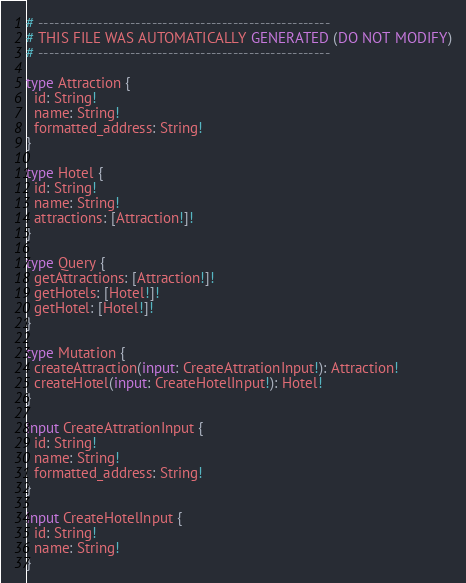Convert code to text. <code><loc_0><loc_0><loc_500><loc_500><_SQL_># ------------------------------------------------------
# THIS FILE WAS AUTOMATICALLY GENERATED (DO NOT MODIFY)
# ------------------------------------------------------

type Attraction {
  id: String!
  name: String!
  formatted_address: String!
}

type Hotel {
  id: String!
  name: String!
  attractions: [Attraction!]!
}

type Query {
  getAttractions: [Attraction!]!
  getHotels: [Hotel!]!
  getHotel: [Hotel!]!
}

type Mutation {
  createAttraction(input: CreateAttrationInput!): Attraction!
  createHotel(input: CreateHotelInput!): Hotel!
}

input CreateAttrationInput {
  id: String!
  name: String!
  formatted_address: String!
}

input CreateHotelInput {
  id: String!
  name: String!
}
</code> 